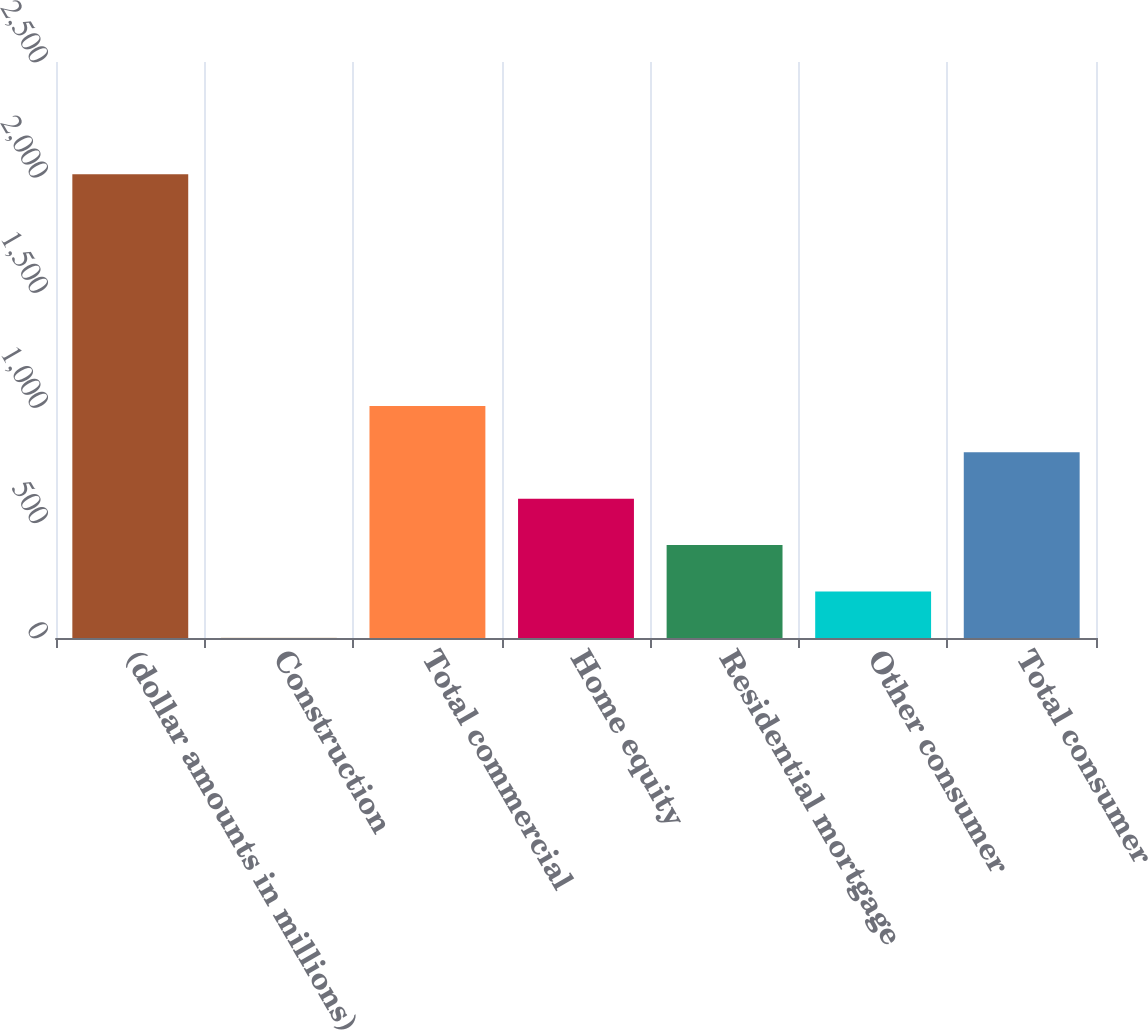Convert chart. <chart><loc_0><loc_0><loc_500><loc_500><bar_chart><fcel>(dollar amounts in millions)<fcel>Construction<fcel>Total commercial<fcel>Home equity<fcel>Residential mortgage<fcel>Other consumer<fcel>Total consumer<nl><fcel>2013<fcel>1<fcel>1007<fcel>604.6<fcel>403.4<fcel>202.2<fcel>805.8<nl></chart> 